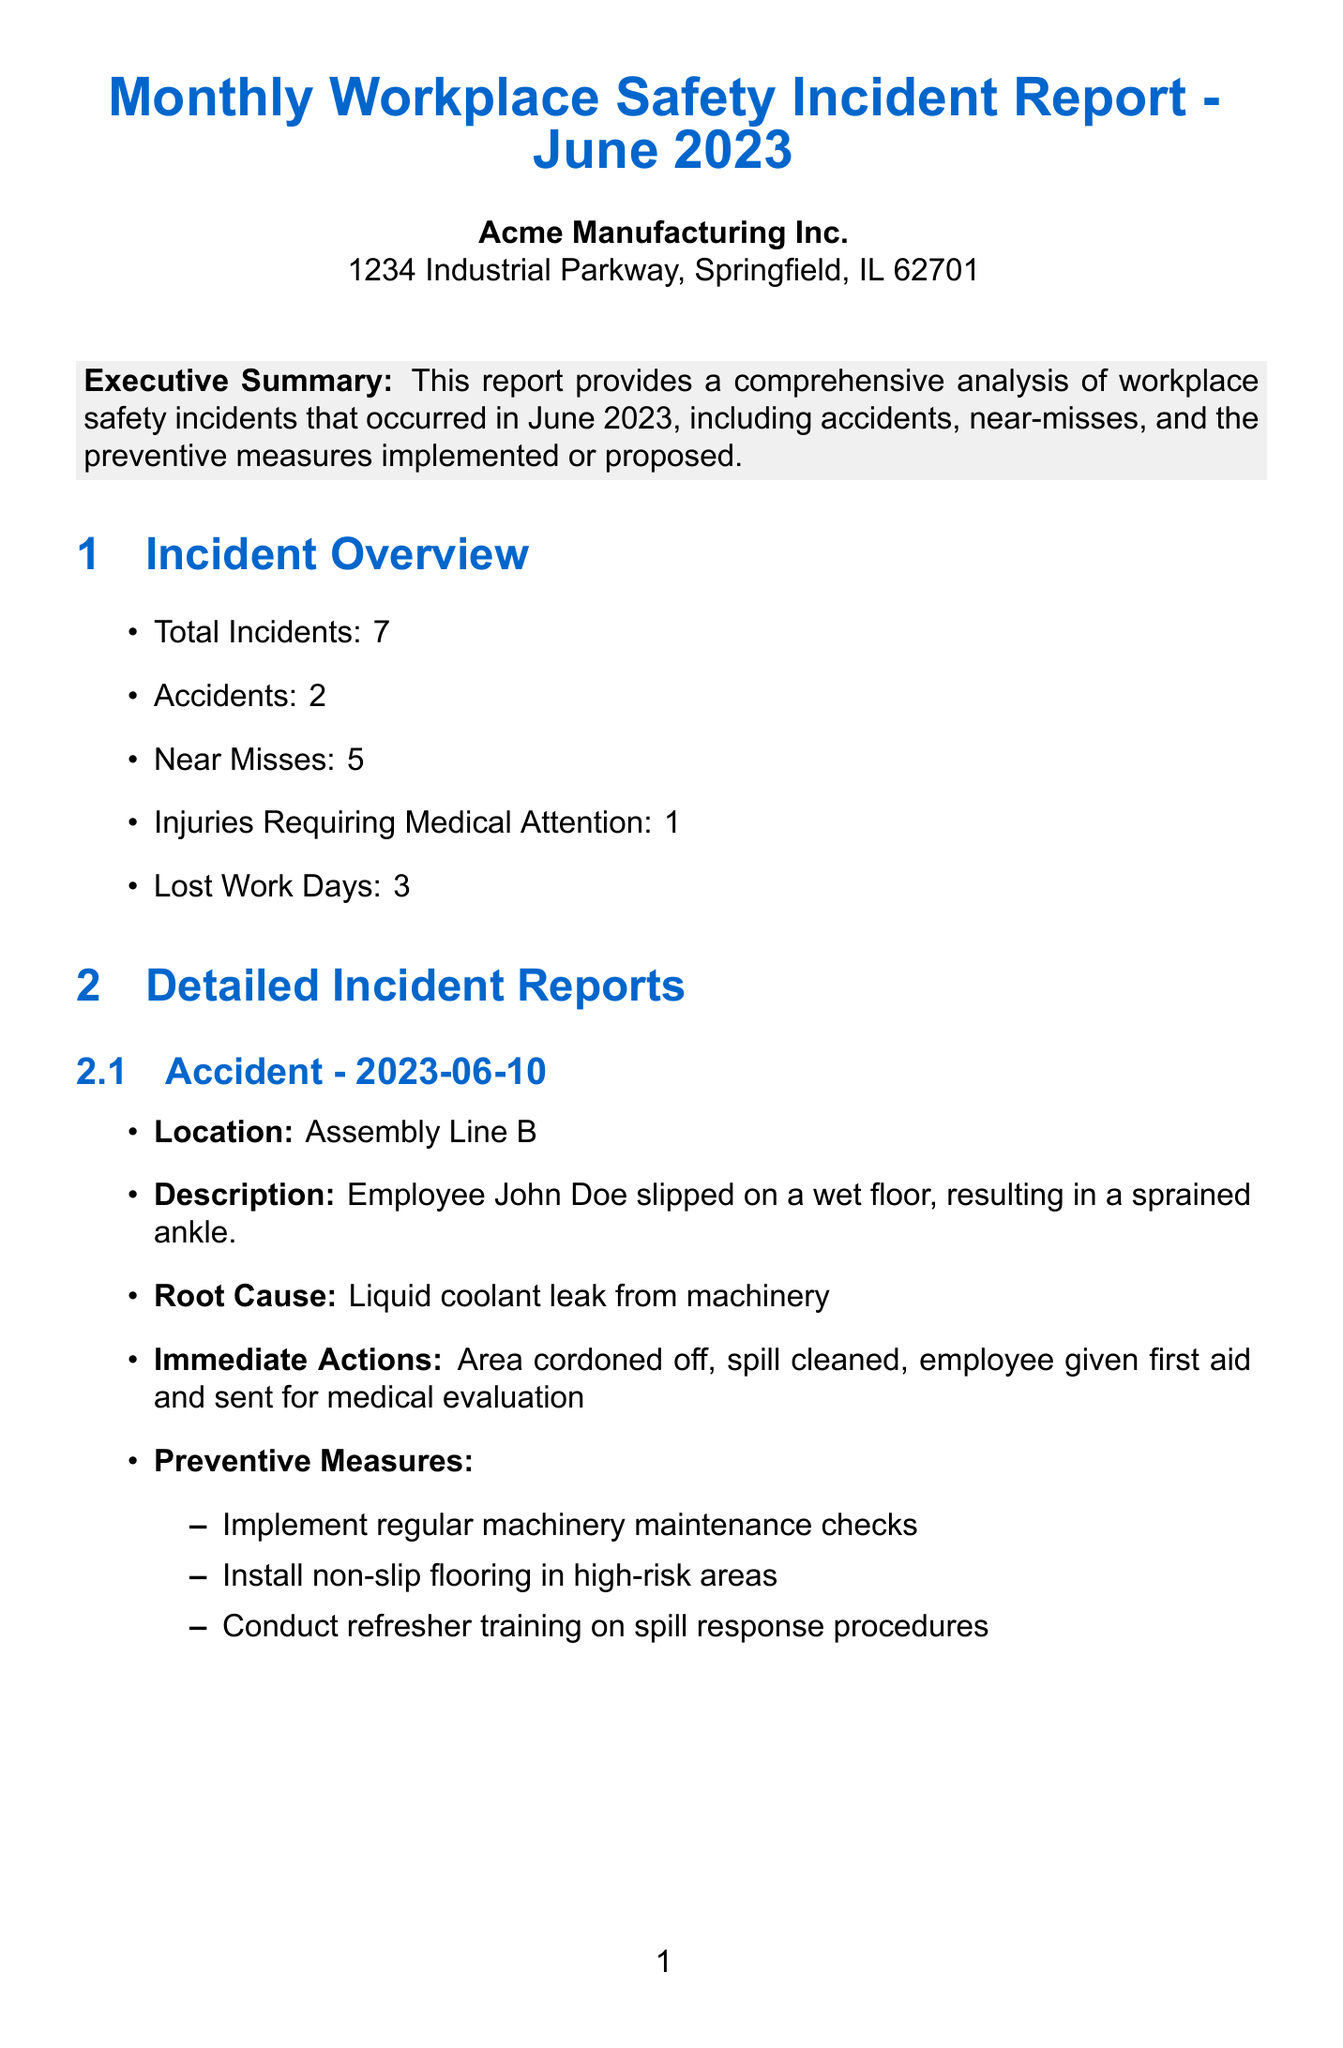What is the total number of incidents reported? The total number of incidents is directly stated in the incident overview section of the document.
Answer: 7 How many accidents occurred in June 2023? The number of accidents is specified in the incident overview section of the document.
Answer: 2 What was the date of the accident involving John Doe? The specific date of the incident is given in the detailed incident reports section under accidents.
Answer: 2023-06-10 What immediate action was taken after the accident on June 10? The immediate actions taken are listed in the detailed incident report for John Doe's accident.
Answer: Area cordoned off, spill cleaned, employee given first aid and sent for medical evaluation What root cause led to the near miss involving Sarah Johnson? The document identifies the root cause of the near miss incident in the detailed report section.
Answer: Poor visibility due to inadequate lighting What is the incident rate reported in the safety performance metrics? The incident rate is one of the safety performance metrics outlined in the report.
Answer: 2.3 What are the two ongoing safety initiatives mentioned in the report? The report details ongoing safety initiatives to show how the company is proactively addressing safety.
Answer: Safety Suggestion Box Program, Monthly Safety Committee Meetings How many employees were trained in June 2023? The total number of employees trained is specified in the employee training record section.
Answer: 75 What is the completion date for the installation of machine guarding? The completion date for this preventive measure is given in the preventive measures implemented section.
Answer: 2023-06-05 